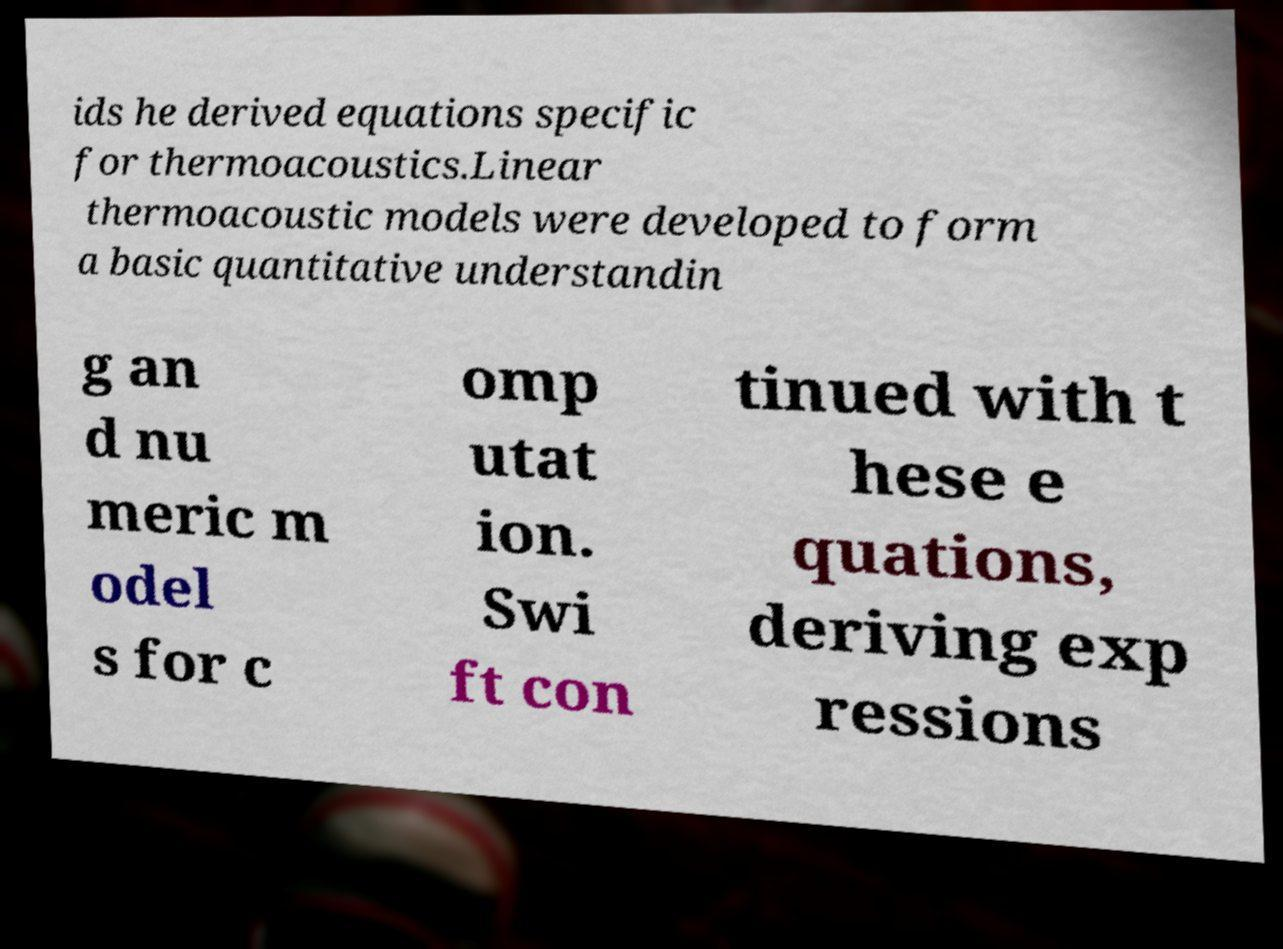Can you read and provide the text displayed in the image?This photo seems to have some interesting text. Can you extract and type it out for me? ids he derived equations specific for thermoacoustics.Linear thermoacoustic models were developed to form a basic quantitative understandin g an d nu meric m odel s for c omp utat ion. Swi ft con tinued with t hese e quations, deriving exp ressions 